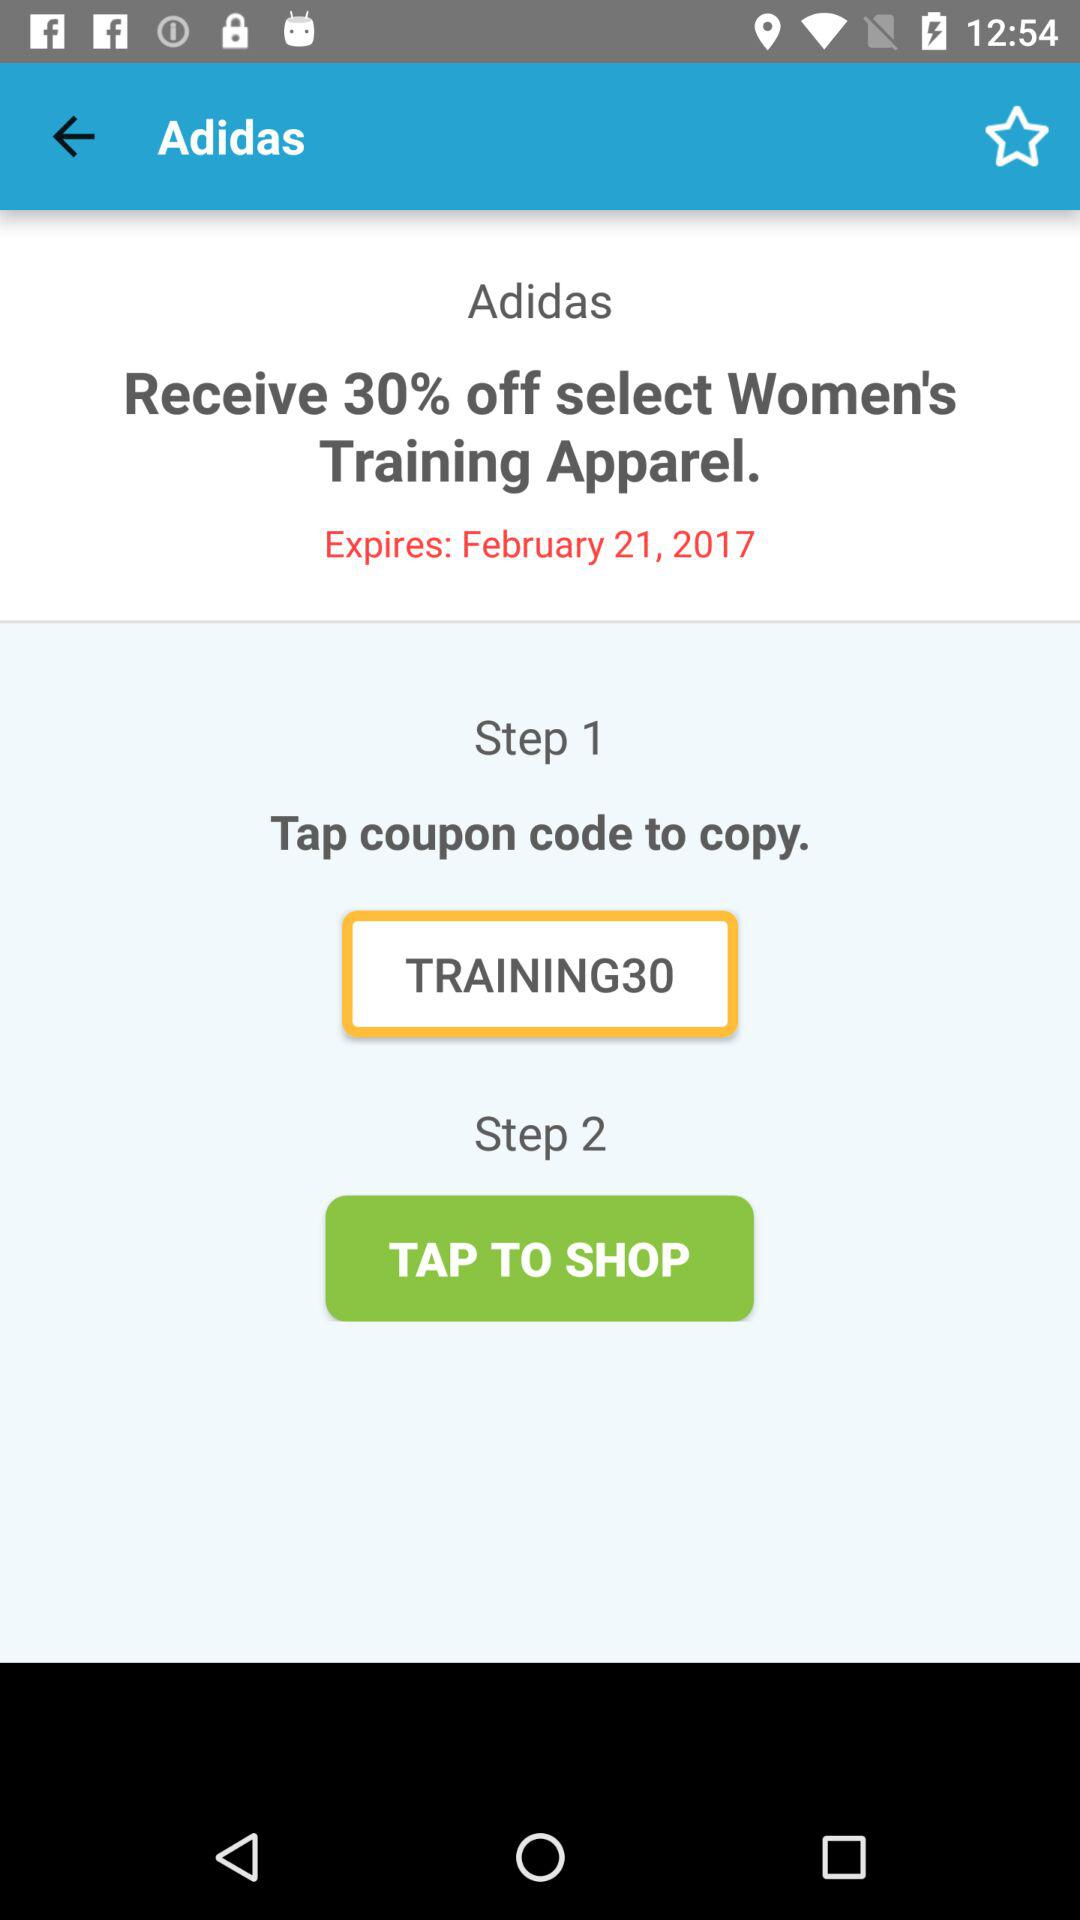What is the percentage discount on "Women's Training Apparel"? The discount on "Women's Training Apparel" is 30%. 